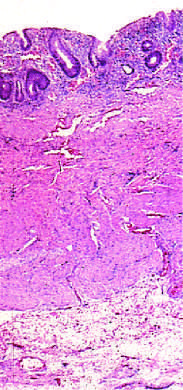what is disease limited to?
Answer the question using a single word or phrase. The mucosa 